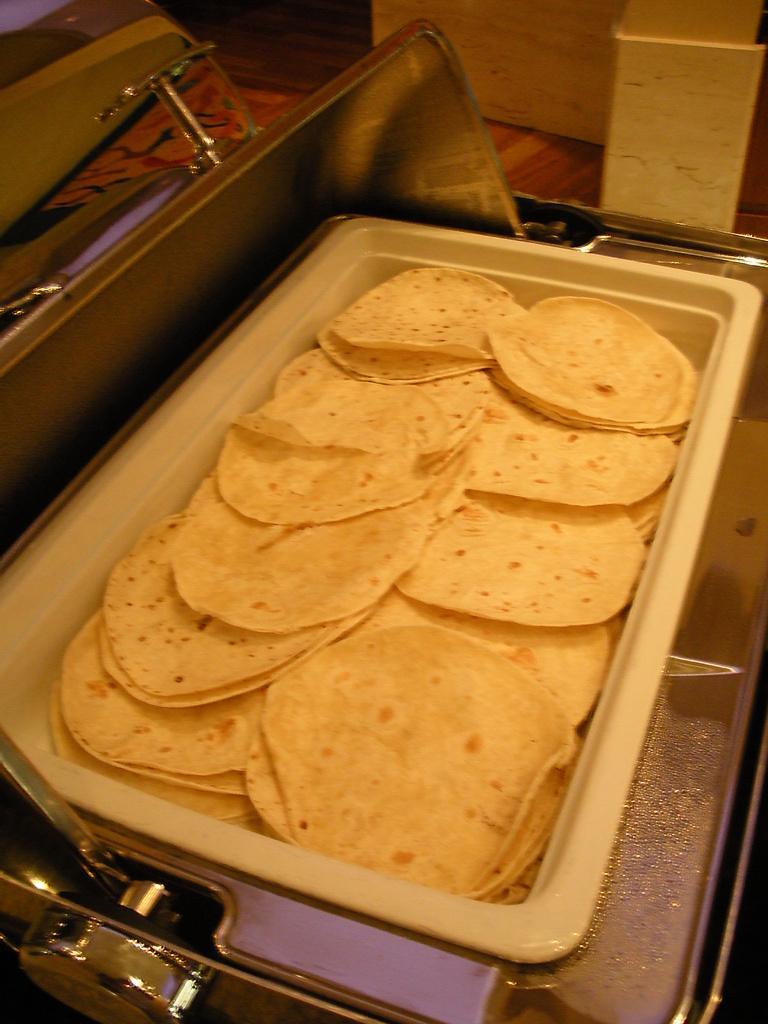Describe this image in one or two sentences. In this picture I can see chapatis in a tray and i can see a covering lid. 